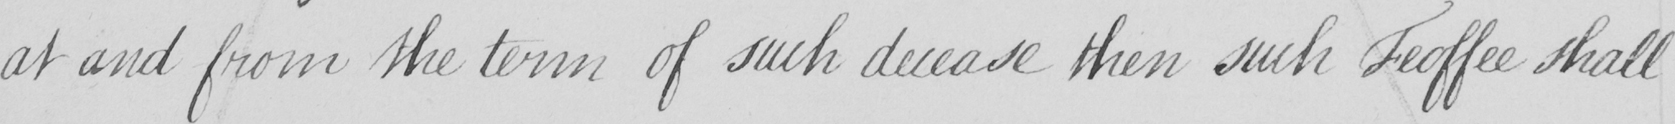Can you tell me what this handwritten text says? at and from the term of such decease then such Feoffee shall 